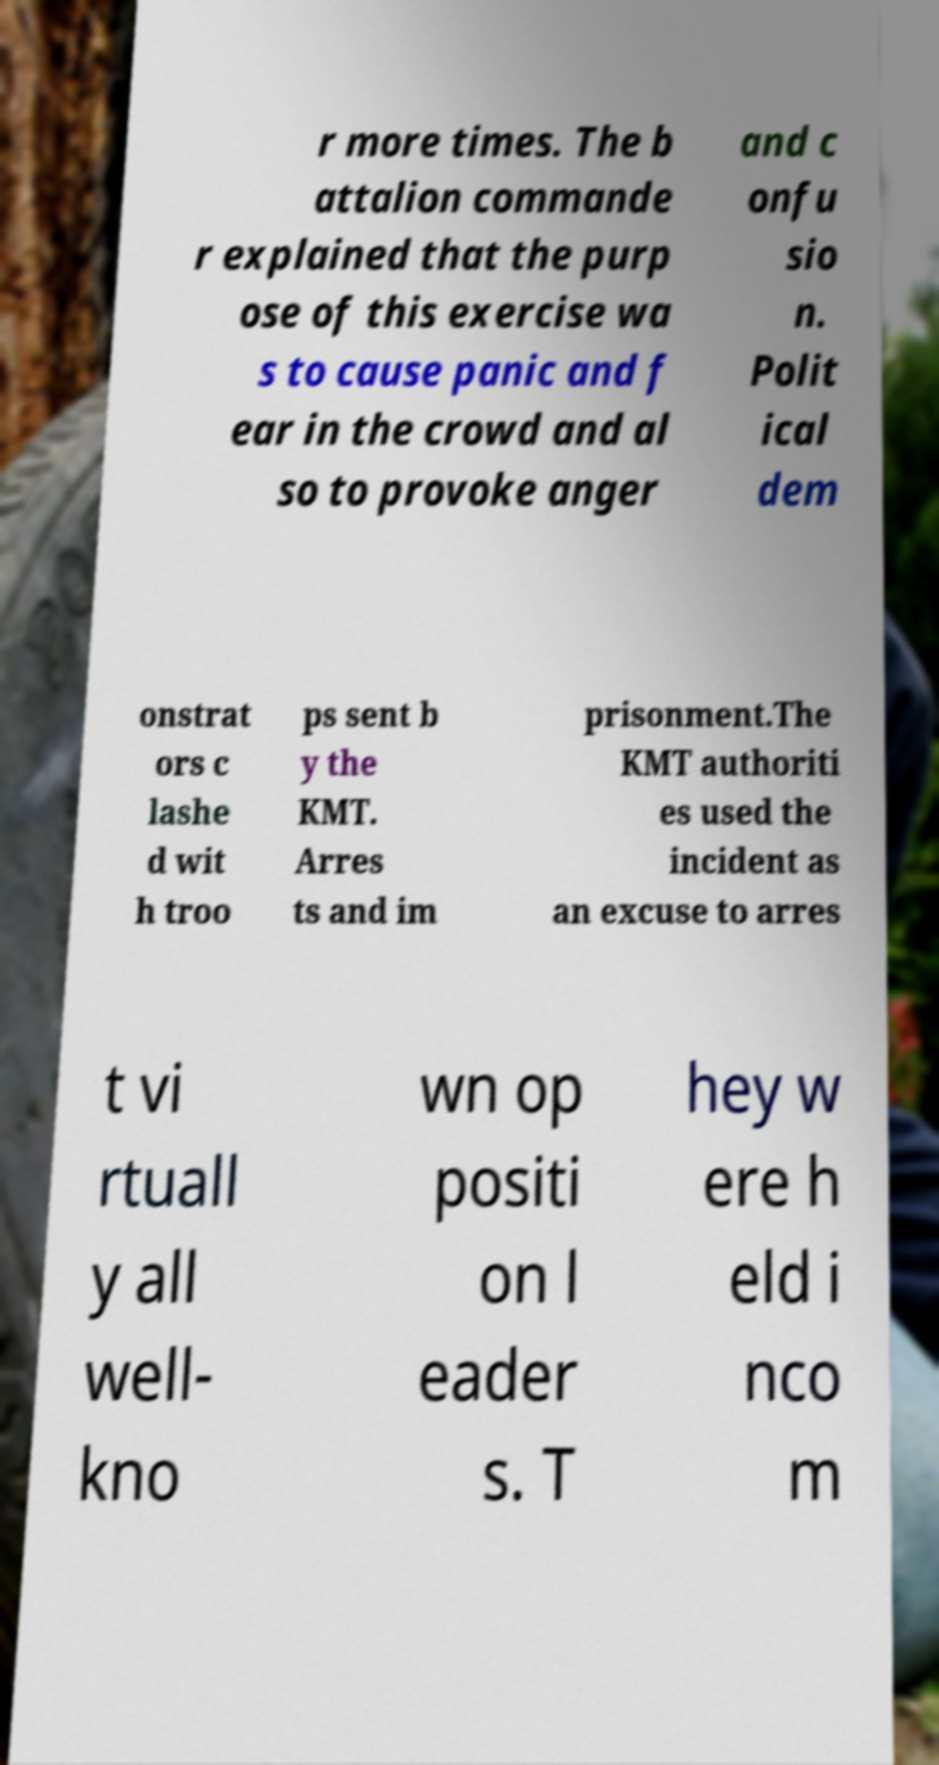Can you accurately transcribe the text from the provided image for me? r more times. The b attalion commande r explained that the purp ose of this exercise wa s to cause panic and f ear in the crowd and al so to provoke anger and c onfu sio n. Polit ical dem onstrat ors c lashe d wit h troo ps sent b y the KMT. Arres ts and im prisonment.The KMT authoriti es used the incident as an excuse to arres t vi rtuall y all well- kno wn op positi on l eader s. T hey w ere h eld i nco m 